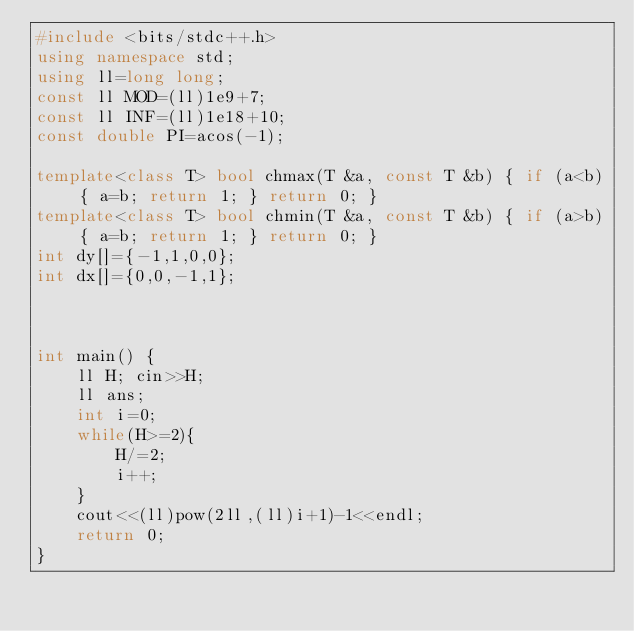Convert code to text. <code><loc_0><loc_0><loc_500><loc_500><_C++_>#include <bits/stdc++.h>
using namespace std;
using ll=long long;
const ll MOD=(ll)1e9+7;
const ll INF=(ll)1e18+10;
const double PI=acos(-1);

template<class T> bool chmax(T &a, const T &b) { if (a<b) { a=b; return 1; } return 0; }
template<class T> bool chmin(T &a, const T &b) { if (a>b) { a=b; return 1; } return 0; }
int dy[]={-1,1,0,0};
int dx[]={0,0,-1,1};



int main() {
    ll H; cin>>H;
    ll ans;
    int i=0;
    while(H>=2){
        H/=2;
        i++;
    }
    cout<<(ll)pow(2ll,(ll)i+1)-1<<endl;
    return 0;
}
</code> 